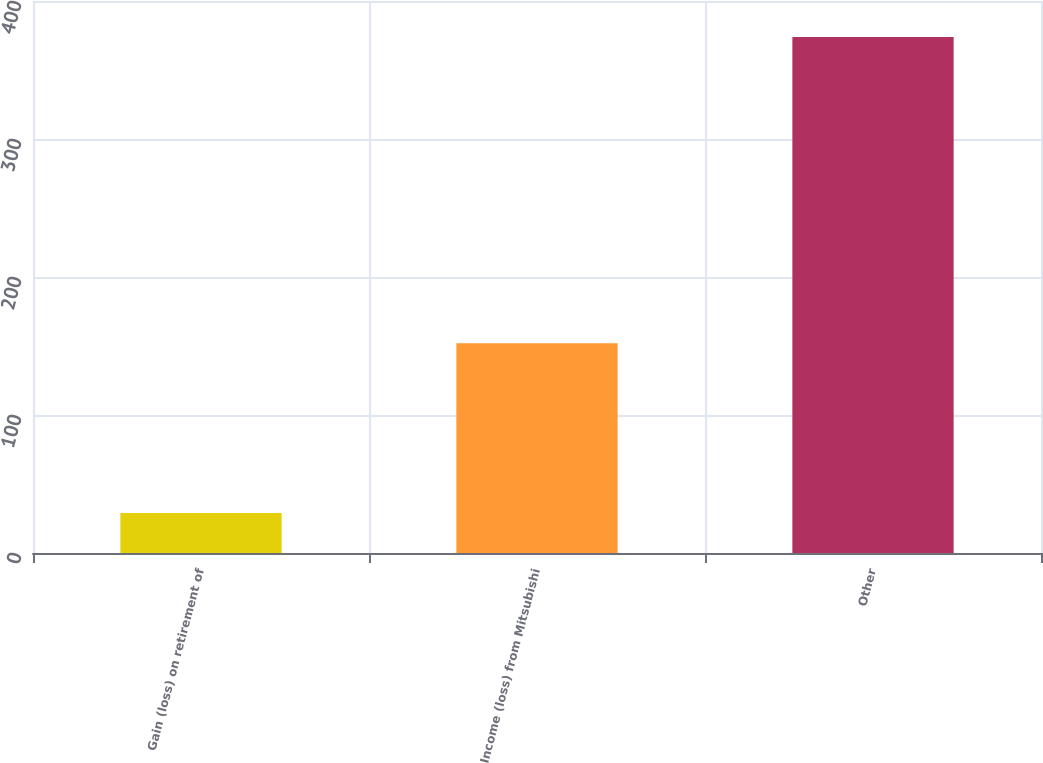Convert chart. <chart><loc_0><loc_0><loc_500><loc_500><bar_chart><fcel>Gain (loss) on retirement of<fcel>Income (loss) from Mitsubishi<fcel>Other<nl><fcel>29<fcel>152<fcel>374<nl></chart> 